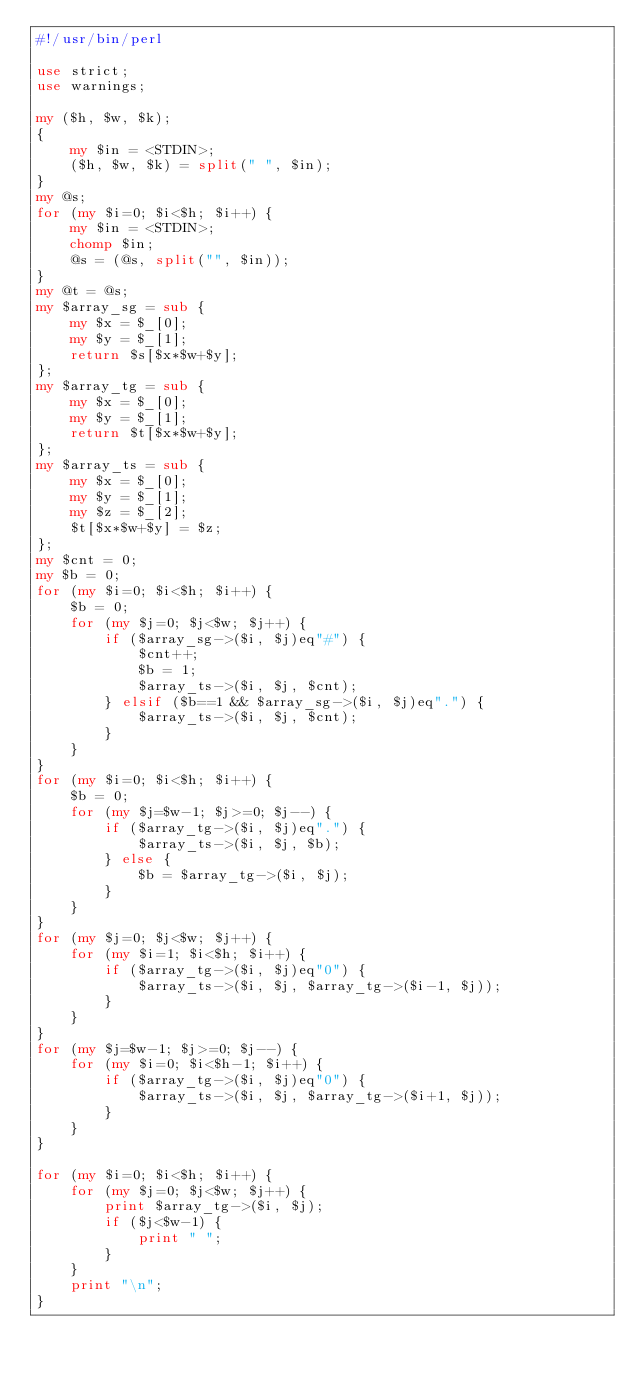<code> <loc_0><loc_0><loc_500><loc_500><_Perl_>#!/usr/bin/perl

use strict;
use warnings;

my ($h, $w, $k);
{
    my $in = <STDIN>;
    ($h, $w, $k) = split(" ", $in);
}
my @s;
for (my $i=0; $i<$h; $i++) {
    my $in = <STDIN>;
    chomp $in;
    @s = (@s, split("", $in));
}
my @t = @s;
my $array_sg = sub {
    my $x = $_[0];
    my $y = $_[1];
    return $s[$x*$w+$y];
};
my $array_tg = sub {
    my $x = $_[0];
    my $y = $_[1];
    return $t[$x*$w+$y];
};
my $array_ts = sub {
    my $x = $_[0];
    my $y = $_[1];
    my $z = $_[2];
    $t[$x*$w+$y] = $z;
};
my $cnt = 0;
my $b = 0;
for (my $i=0; $i<$h; $i++) {
    $b = 0;
    for (my $j=0; $j<$w; $j++) {
        if ($array_sg->($i, $j)eq"#") {
            $cnt++;
            $b = 1;
            $array_ts->($i, $j, $cnt);
        } elsif ($b==1 && $array_sg->($i, $j)eq".") {
            $array_ts->($i, $j, $cnt);
        }        
    }
}
for (my $i=0; $i<$h; $i++) {
    $b = 0;
    for (my $j=$w-1; $j>=0; $j--) {
        if ($array_tg->($i, $j)eq".") {
            $array_ts->($i, $j, $b);
        } else {
            $b = $array_tg->($i, $j);
        }
    }
}
for (my $j=0; $j<$w; $j++) {
    for (my $i=1; $i<$h; $i++) {
        if ($array_tg->($i, $j)eq"0") {
            $array_ts->($i, $j, $array_tg->($i-1, $j));
        }
    }
}
for (my $j=$w-1; $j>=0; $j--) {
    for (my $i=0; $i<$h-1; $i++) {
        if ($array_tg->($i, $j)eq"0") {
            $array_ts->($i, $j, $array_tg->($i+1, $j));
        }
    }
}

for (my $i=0; $i<$h; $i++) {
    for (my $j=0; $j<$w; $j++) {
        print $array_tg->($i, $j);
        if ($j<$w-1) {
            print " ";
        }
    }
    print "\n";
}</code> 